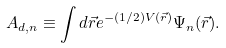Convert formula to latex. <formula><loc_0><loc_0><loc_500><loc_500>A _ { d , n } \equiv \int d \vec { r } e ^ { - ( 1 / 2 ) V ( \vec { r } ) } \Psi _ { n } ( \vec { r } ) .</formula> 